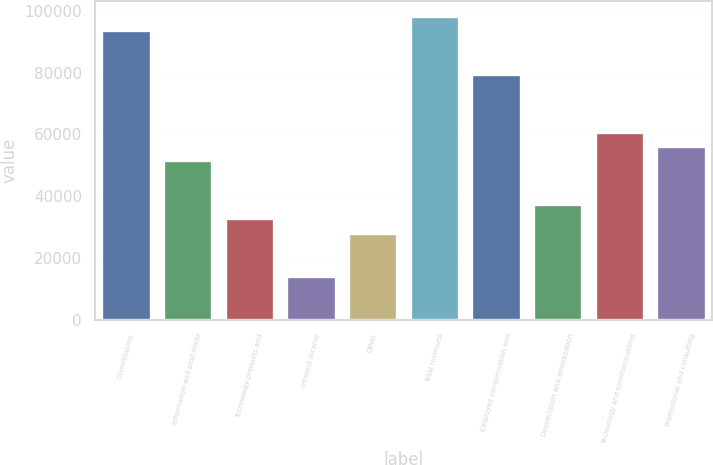<chart> <loc_0><loc_0><loc_500><loc_500><bar_chart><fcel>Commissions<fcel>Information and post-trade<fcel>Technology products and<fcel>Interest income<fcel>Other<fcel>Total revenues<fcel>Employee compensation and<fcel>Depreciation and amortization<fcel>Technology and communications<fcel>Professional and consulting<nl><fcel>93754<fcel>51564.7<fcel>32813.9<fcel>14063.1<fcel>28126.2<fcel>98441.7<fcel>79690.9<fcel>37501.6<fcel>60940.1<fcel>56252.4<nl></chart> 